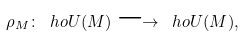Convert formula to latex. <formula><loc_0><loc_0><loc_500><loc_500>\rho _ { M } \colon \ h o U \AA ( M ) \longrightarrow \ h o U \AA ( M ) ,</formula> 